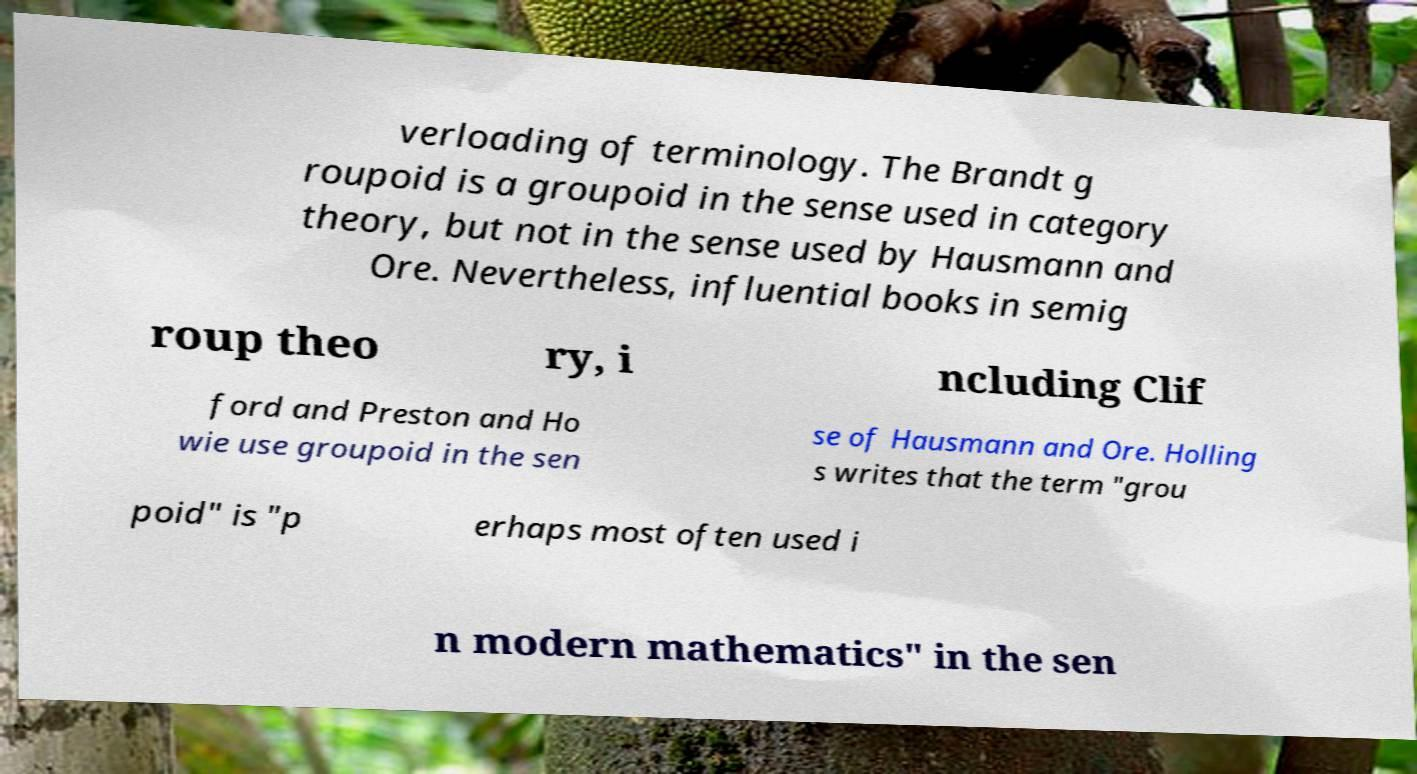Can you accurately transcribe the text from the provided image for me? verloading of terminology. The Brandt g roupoid is a groupoid in the sense used in category theory, but not in the sense used by Hausmann and Ore. Nevertheless, influential books in semig roup theo ry, i ncluding Clif ford and Preston and Ho wie use groupoid in the sen se of Hausmann and Ore. Holling s writes that the term "grou poid" is "p erhaps most often used i n modern mathematics" in the sen 